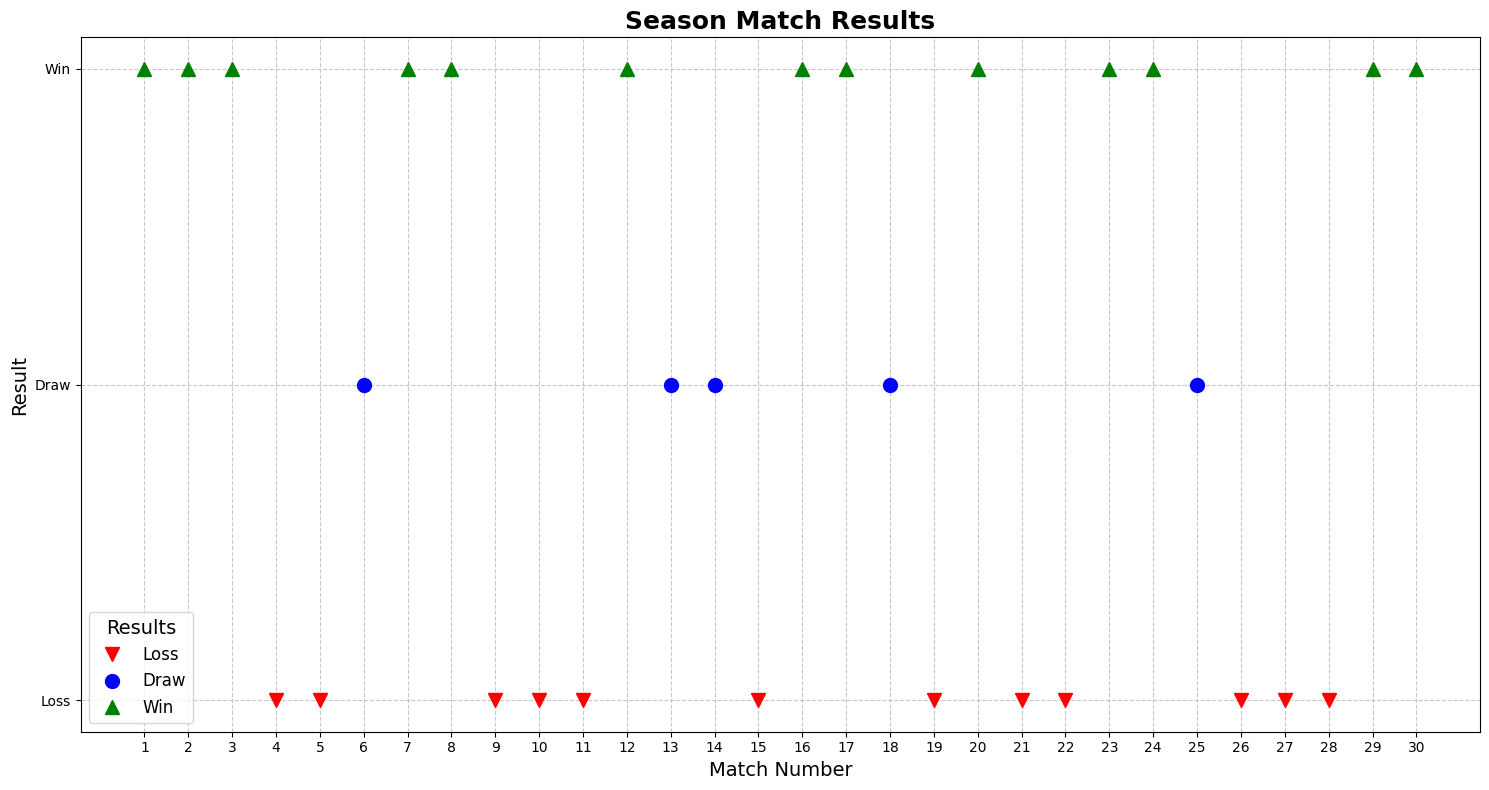Which match has the longest string of consecutive wins? To find the longest consecutive win streak, we look for the longest sequence of green triangle markers. The longest win streak occurs between match 1 to match 3.
Answer: 3 How many total matches ended in a draw? Count the number of blue circle markers in the figure. There are 5 draw markers.
Answer: 5 What is the overall count of losses in the season? Count the number of red downward-pointing triangle markers in the plot. There are 11 loss markers.
Answer: 11 How does the number of wins compare to the number of losses? Count the number of wins (green triangles) and compare them to the number of losses (red triangles). There are 12 wins compared to 11 losses.
Answer: Wins are 1 more than losses Which match number has a draw followed immediately by a win? Identify draws (blue circles) followed by wins (green triangles). From the plot, match 12 (win) immediately follows match 13 (draw).
Answer: Match 12 How often do losses occur consecutively more than twice? Look for sequences of red triangles where the length of the sequence is greater than two. There is only one such sequence: matches 9 to 11.
Answer: 1 time What is the most common result after a draw? Look at the result immediately after each blue circle marker. The most common following result is a loss (occurs after matches 13, 14 and 18).
Answer: Loss What's the average number of matches between each draw? Count the matches between draws and calculate the average: match 1 to 6 (5 matches), match 6 to 12 (6 matches), match 12 to 13 (1 match), match 13 to 18 (5 matches), match 18 to 25 (7 matches). Average = (5+6+1+5+7)/5 = 4.8 matches.
Answer: 4.8 matches Which match has the shortest interval between a win and the next loss? Look for consecutive sequences of a green triangle followed immediately by a red triangle. Match 3 (win) followed immediately by match 4 (loss) shows the shortest interval.
Answer: Match 4 